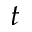<formula> <loc_0><loc_0><loc_500><loc_500>t</formula> 